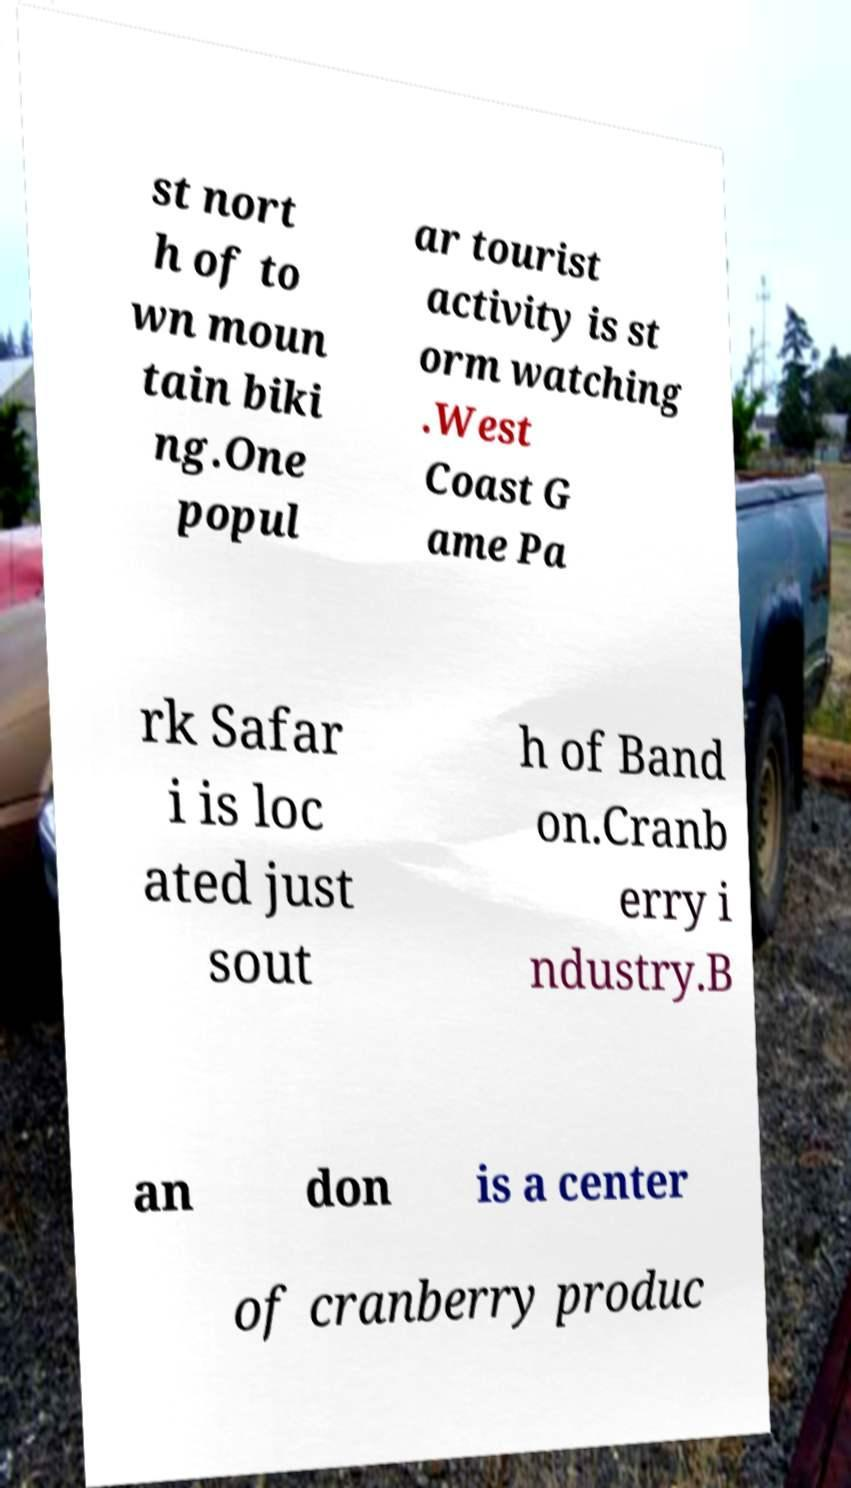Can you accurately transcribe the text from the provided image for me? st nort h of to wn moun tain biki ng.One popul ar tourist activity is st orm watching .West Coast G ame Pa rk Safar i is loc ated just sout h of Band on.Cranb erry i ndustry.B an don is a center of cranberry produc 